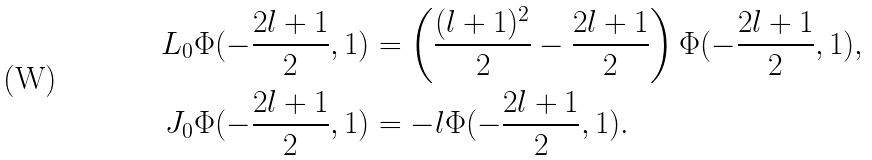Convert formula to latex. <formula><loc_0><loc_0><loc_500><loc_500>L _ { 0 } \Phi ( - \frac { 2 l + 1 } { 2 } , 1 ) & = \left ( \frac { ( l + 1 ) ^ { 2 } } { 2 } - \frac { 2 l + 1 } { 2 } \right ) \Phi ( - \frac { 2 l + 1 } { 2 } , 1 ) , \\ J _ { 0 } \Phi ( - \frac { 2 l + 1 } { 2 } , 1 ) & = - l \Phi ( - \frac { 2 l + 1 } { 2 } , 1 ) .</formula> 